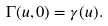Convert formula to latex. <formula><loc_0><loc_0><loc_500><loc_500>\Gamma ( u , 0 ) = \gamma ( u ) .</formula> 